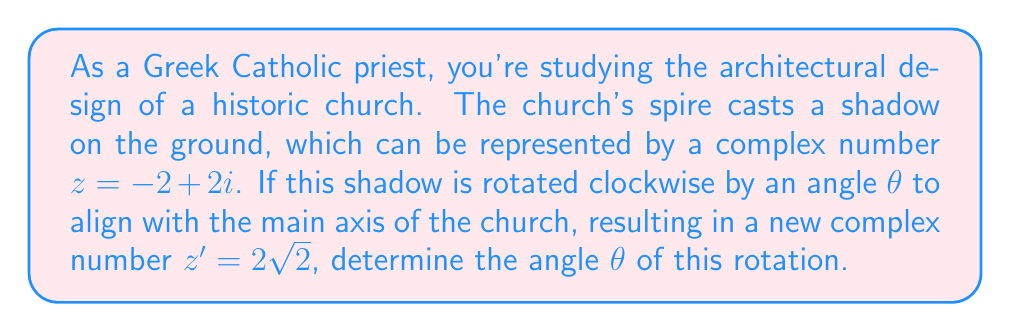What is the answer to this math problem? To solve this problem, we'll follow these steps:

1) First, recall that rotating a complex number $z$ by an angle $\theta$ clockwise is equivalent to multiplying it by $e^{-i\theta}$. So we have:

   $z' = ze^{-i\theta}$

2) We're given that $z = -2 + 2i$ and $z' = 2\sqrt{2}$. Let's substitute these:

   $2\sqrt{2} = (-2 + 2i)e^{-i\theta}$

3) To solve for $\theta$, let's first find the modulus and argument of $z$:

   $|z| = \sqrt{(-2)^2 + 2^2} = 2\sqrt{2}$
   $\arg(z) = \arctan(\frac{2}{-2}) + \pi = \frac{3\pi}{4}$

4) We can now rewrite $z$ in polar form:

   $z = 2\sqrt{2}e^{i\frac{3\pi}{4}}$

5) Substituting this back into our equation:

   $2\sqrt{2} = 2\sqrt{2}e^{i\frac{3\pi}{4}}e^{-i\theta}$

6) The moduli on both sides are equal, so we can focus on the arguments:

   $0 = \frac{3\pi}{4} - \theta$

7) Solving for $\theta$:

   $\theta = \frac{3\pi}{4}$

8) Convert to degrees:

   $\theta = \frac{3\pi}{4} \cdot \frac{180^\circ}{\pi} = 135^\circ$

Therefore, the shadow needs to be rotated $135^\circ$ clockwise to align with the main axis of the church.
Answer: $\theta = 135^\circ$ or $\frac{3\pi}{4}$ radians 